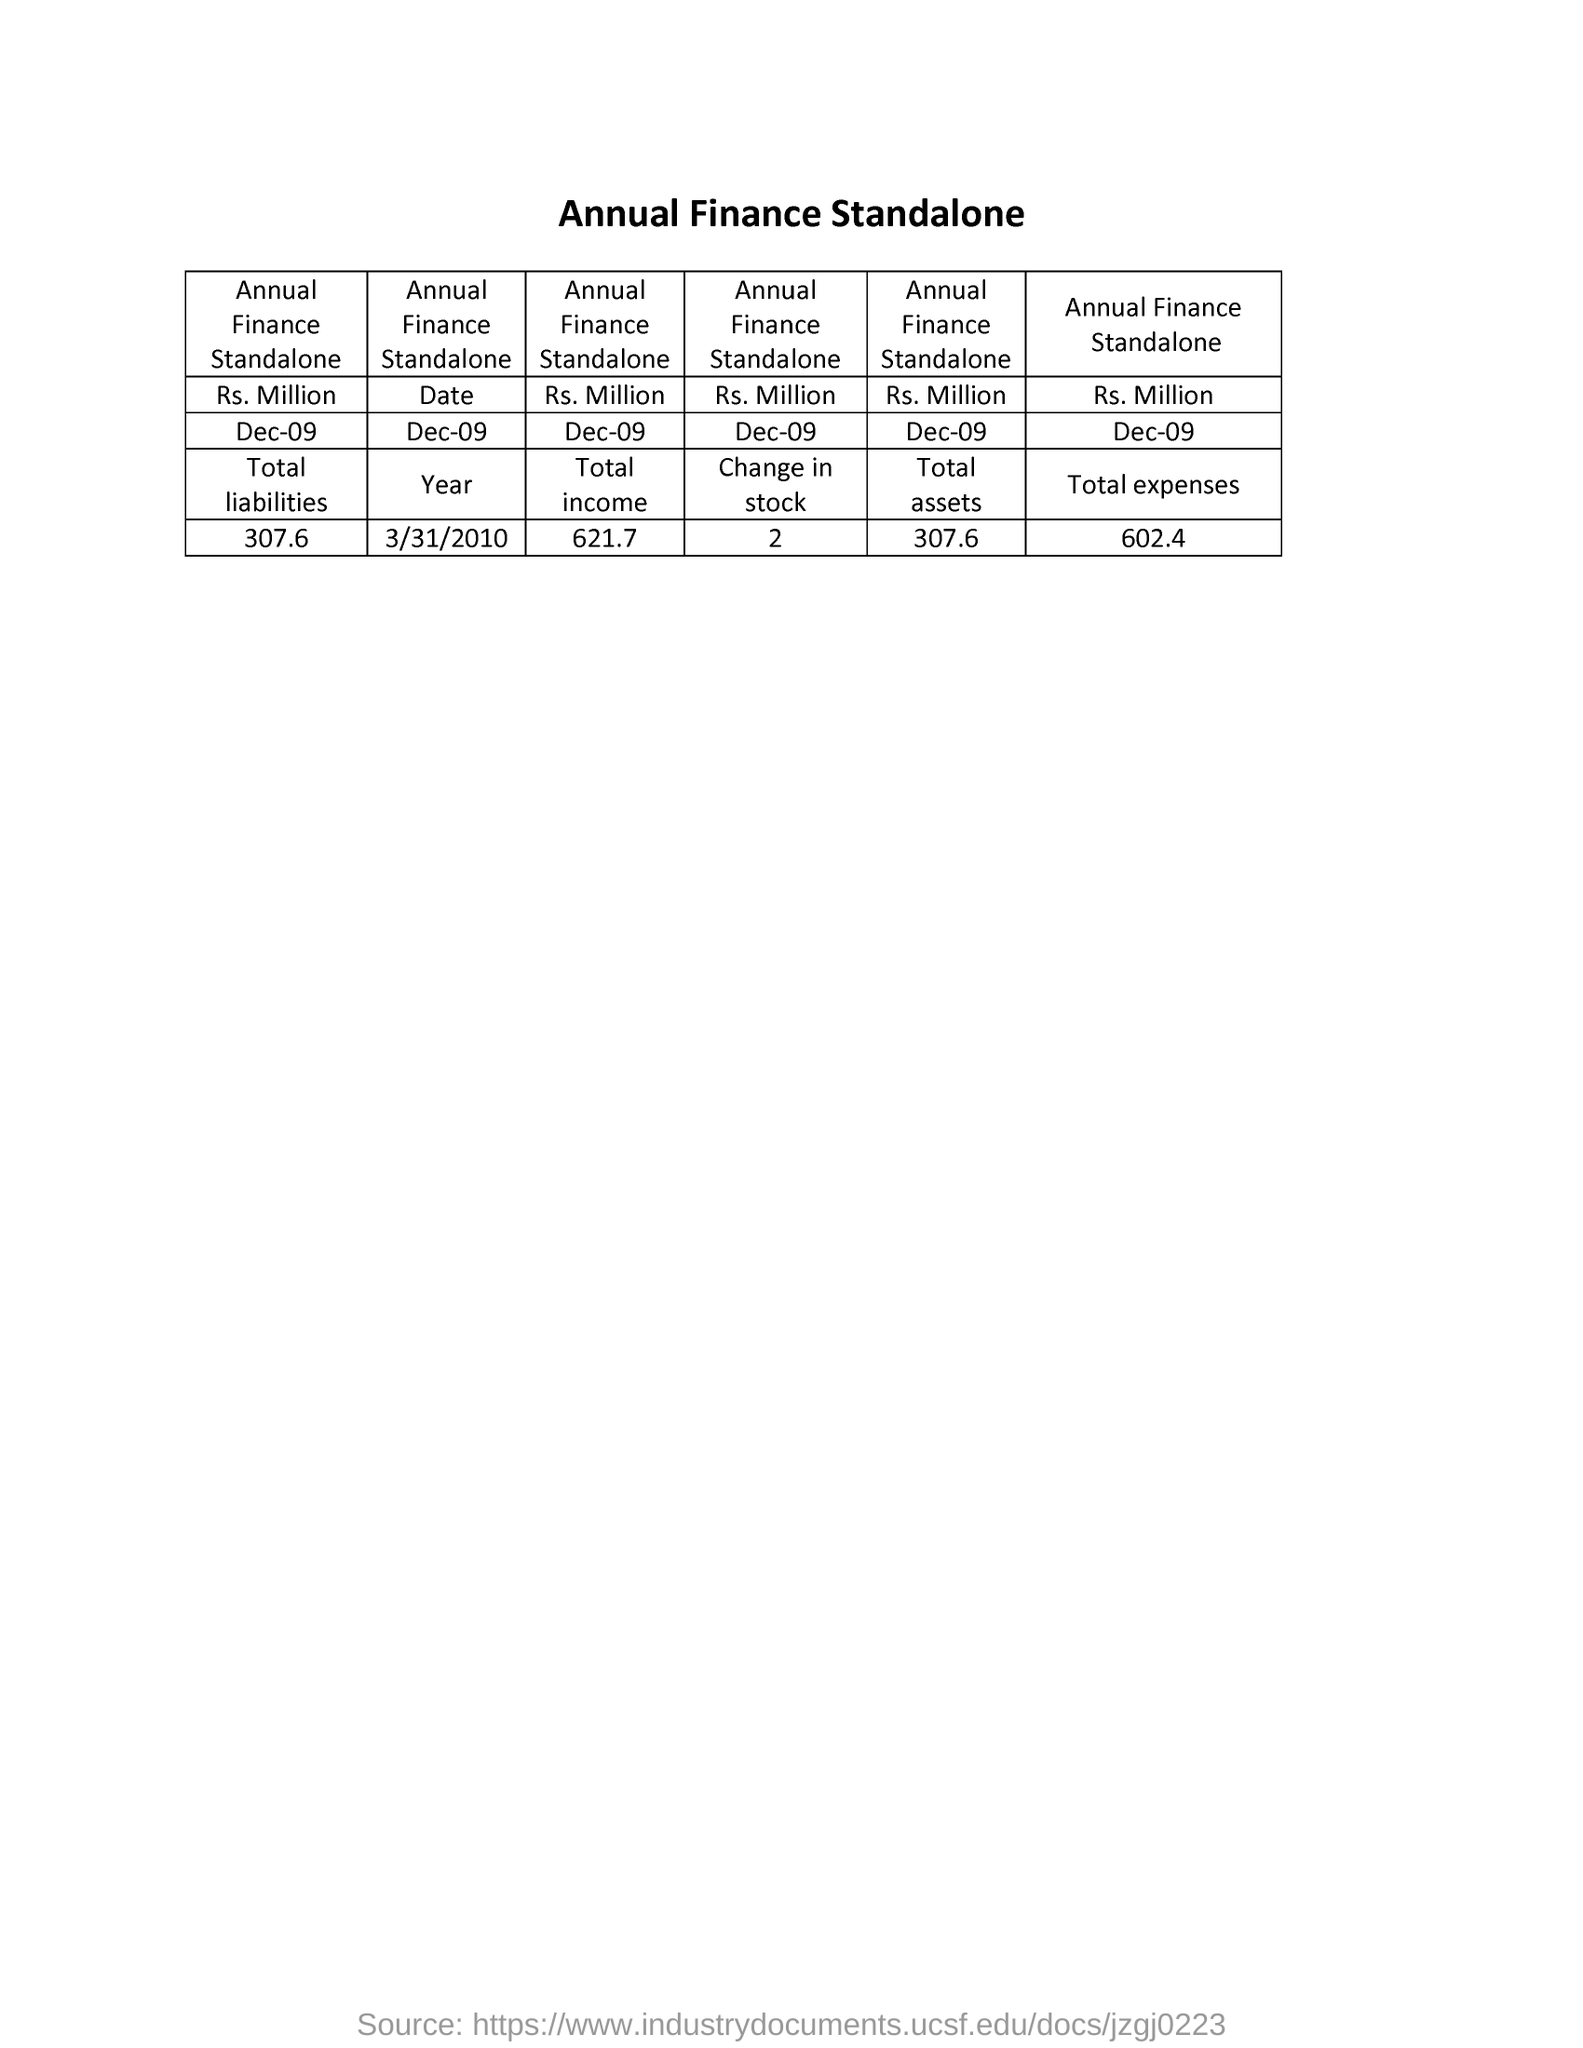What is the value given under "Total liabilities"?
Offer a terse response. 307.6. What is the date given under "year"?
Make the answer very short. 3/31/2010. What is the value of  "Total income" given?
Offer a very short reply. 621.7. Mention the value of "Total assets" of Annual Finance Standalone?
Your response must be concise. 307.6. Mention the value of "Change in stock"?
Your answer should be compact. 2. Mention the value of "Total expenses" of Annual Finance Standalone?
Provide a short and direct response. 602.4. 